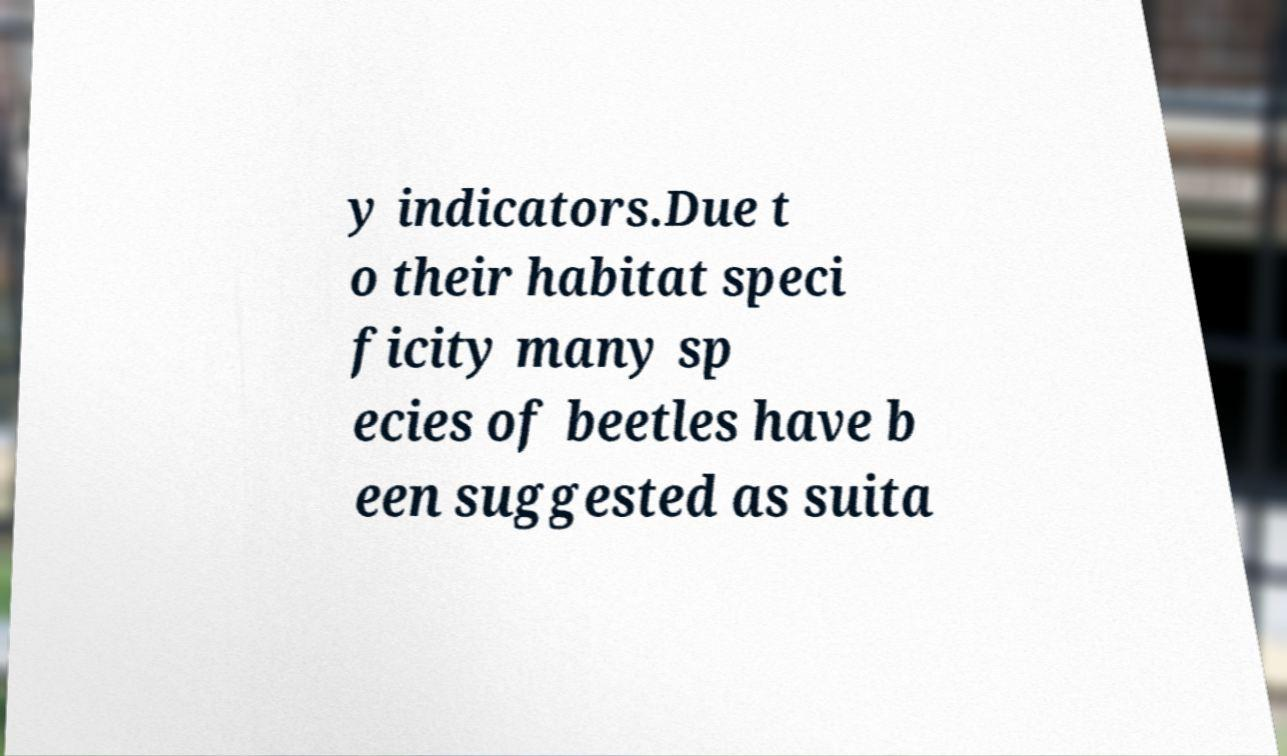For documentation purposes, I need the text within this image transcribed. Could you provide that? y indicators.Due t o their habitat speci ficity many sp ecies of beetles have b een suggested as suita 